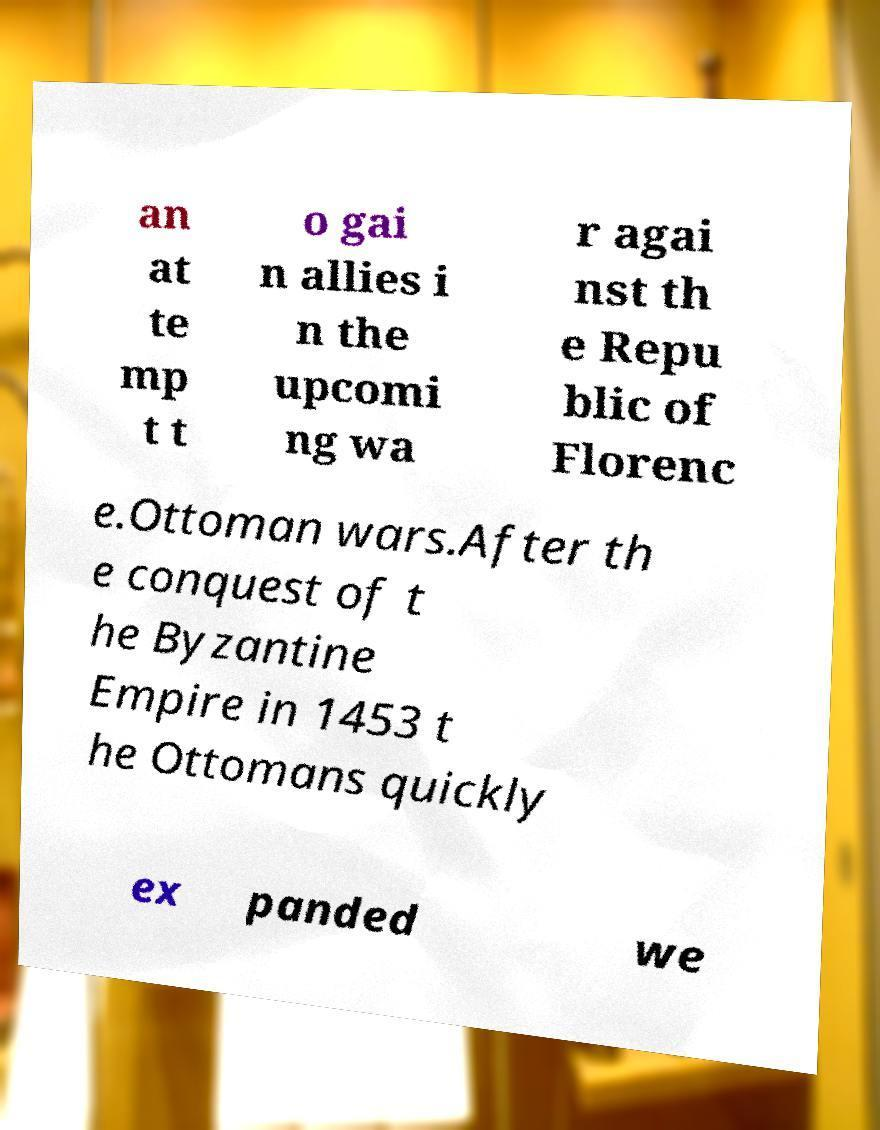Please read and relay the text visible in this image. What does it say? an at te mp t t o gai n allies i n the upcomi ng wa r agai nst th e Repu blic of Florenc e.Ottoman wars.After th e conquest of t he Byzantine Empire in 1453 t he Ottomans quickly ex panded we 